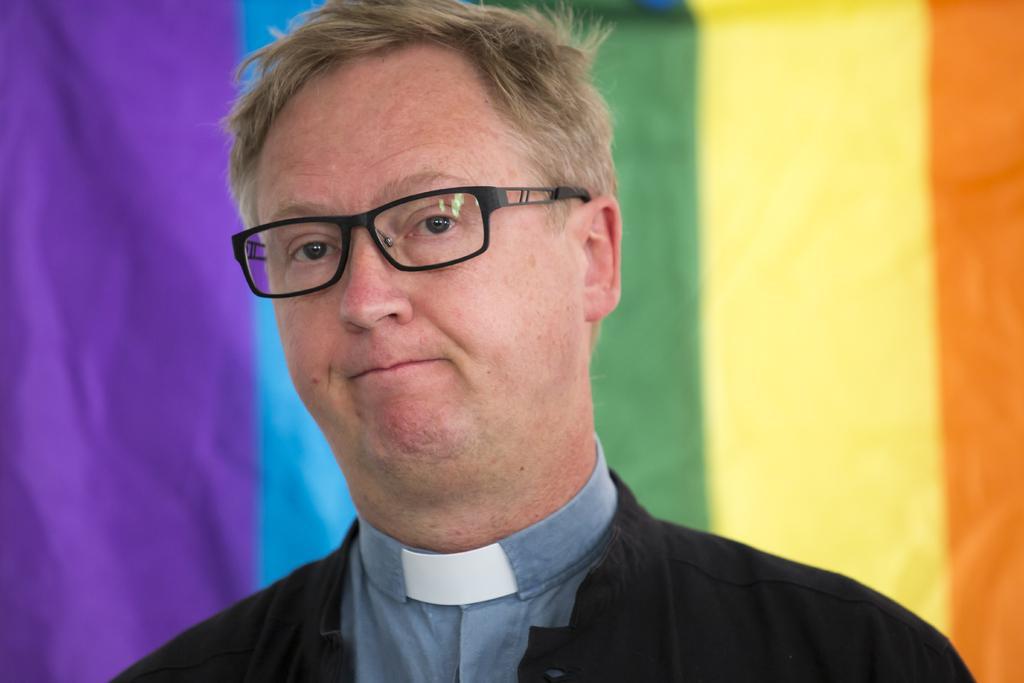Could you give a brief overview of what you see in this image? In the image there is an man with black specks and black shirt standing in front of wall with colorful paintings on it. 